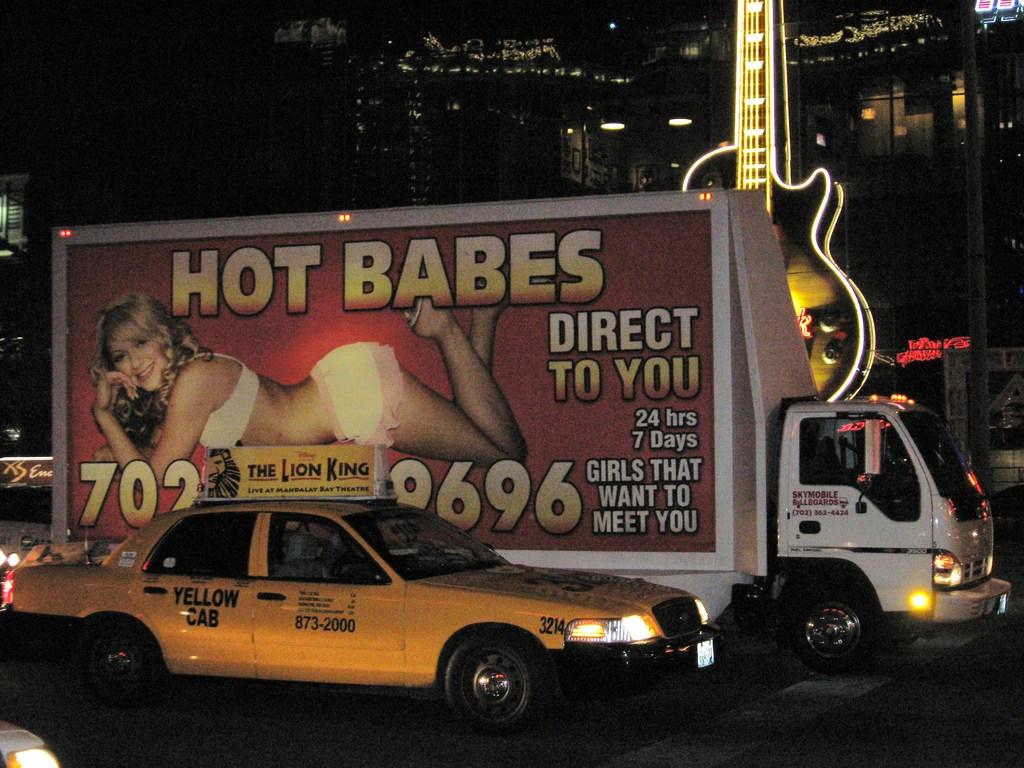How many hours a day do girls want to meet you?
Provide a succinct answer. 24. What does the sign say is hot?
Offer a terse response. Babes. 